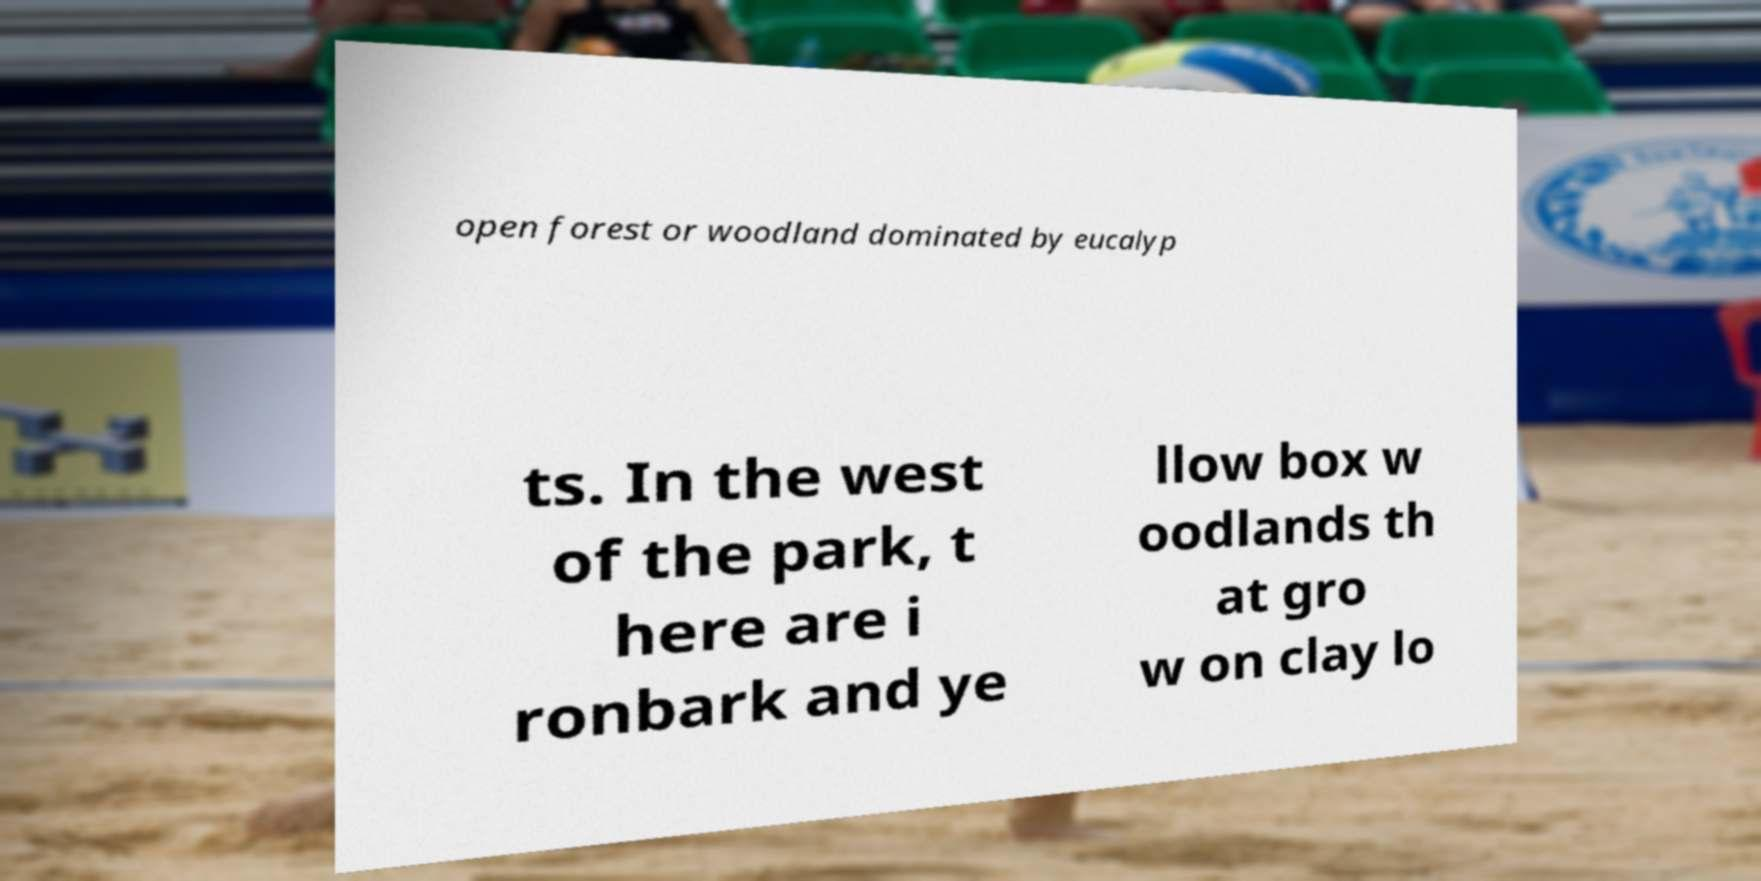Could you extract and type out the text from this image? open forest or woodland dominated by eucalyp ts. In the west of the park, t here are i ronbark and ye llow box w oodlands th at gro w on clay lo 